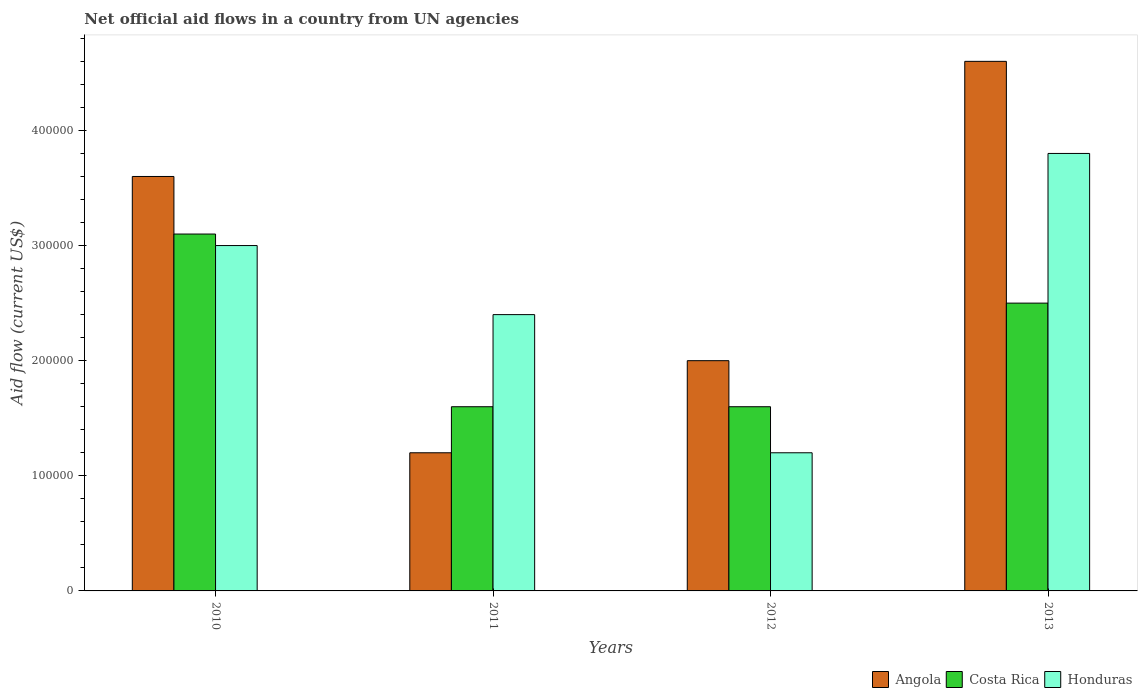How many different coloured bars are there?
Give a very brief answer. 3. Are the number of bars per tick equal to the number of legend labels?
Provide a succinct answer. Yes. Are the number of bars on each tick of the X-axis equal?
Offer a terse response. Yes. In how many cases, is the number of bars for a given year not equal to the number of legend labels?
Your answer should be very brief. 0. What is the net official aid flow in Honduras in 2011?
Give a very brief answer. 2.40e+05. Across all years, what is the maximum net official aid flow in Honduras?
Your answer should be compact. 3.80e+05. Across all years, what is the minimum net official aid flow in Honduras?
Offer a terse response. 1.20e+05. What is the total net official aid flow in Costa Rica in the graph?
Offer a very short reply. 8.80e+05. What is the difference between the net official aid flow in Angola in 2010 and that in 2013?
Make the answer very short. -1.00e+05. What is the difference between the net official aid flow in Costa Rica in 2011 and the net official aid flow in Angola in 2012?
Offer a terse response. -4.00e+04. In the year 2010, what is the difference between the net official aid flow in Honduras and net official aid flow in Angola?
Your answer should be very brief. -6.00e+04. In how many years, is the net official aid flow in Costa Rica greater than 320000 US$?
Provide a short and direct response. 0. What is the ratio of the net official aid flow in Angola in 2012 to that in 2013?
Provide a short and direct response. 0.43. Is the difference between the net official aid flow in Honduras in 2011 and 2013 greater than the difference between the net official aid flow in Angola in 2011 and 2013?
Provide a succinct answer. Yes. What is the difference between the highest and the second highest net official aid flow in Costa Rica?
Give a very brief answer. 6.00e+04. What is the difference between the highest and the lowest net official aid flow in Angola?
Offer a very short reply. 3.40e+05. Is the sum of the net official aid flow in Honduras in 2011 and 2013 greater than the maximum net official aid flow in Angola across all years?
Give a very brief answer. Yes. What does the 3rd bar from the left in 2012 represents?
Your response must be concise. Honduras. What does the 1st bar from the right in 2012 represents?
Ensure brevity in your answer.  Honduras. Is it the case that in every year, the sum of the net official aid flow in Angola and net official aid flow in Honduras is greater than the net official aid flow in Costa Rica?
Keep it short and to the point. Yes. How many bars are there?
Your response must be concise. 12. Where does the legend appear in the graph?
Provide a short and direct response. Bottom right. How are the legend labels stacked?
Ensure brevity in your answer.  Horizontal. What is the title of the graph?
Offer a very short reply. Net official aid flows in a country from UN agencies. What is the Aid flow (current US$) in Angola in 2010?
Offer a very short reply. 3.60e+05. What is the Aid flow (current US$) in Honduras in 2010?
Ensure brevity in your answer.  3.00e+05. What is the Aid flow (current US$) of Costa Rica in 2011?
Offer a very short reply. 1.60e+05. What is the Aid flow (current US$) in Honduras in 2011?
Offer a terse response. 2.40e+05. What is the Aid flow (current US$) of Angola in 2012?
Your answer should be very brief. 2.00e+05. What is the Aid flow (current US$) in Costa Rica in 2012?
Make the answer very short. 1.60e+05. What is the Aid flow (current US$) of Costa Rica in 2013?
Keep it short and to the point. 2.50e+05. What is the Aid flow (current US$) of Honduras in 2013?
Ensure brevity in your answer.  3.80e+05. Across all years, what is the minimum Aid flow (current US$) in Costa Rica?
Your response must be concise. 1.60e+05. What is the total Aid flow (current US$) in Angola in the graph?
Make the answer very short. 1.14e+06. What is the total Aid flow (current US$) in Costa Rica in the graph?
Offer a very short reply. 8.80e+05. What is the total Aid flow (current US$) in Honduras in the graph?
Your answer should be very brief. 1.04e+06. What is the difference between the Aid flow (current US$) in Angola in 2010 and that in 2011?
Give a very brief answer. 2.40e+05. What is the difference between the Aid flow (current US$) of Costa Rica in 2010 and that in 2011?
Keep it short and to the point. 1.50e+05. What is the difference between the Aid flow (current US$) in Honduras in 2010 and that in 2011?
Your answer should be very brief. 6.00e+04. What is the difference between the Aid flow (current US$) in Honduras in 2010 and that in 2012?
Offer a very short reply. 1.80e+05. What is the difference between the Aid flow (current US$) in Costa Rica in 2010 and that in 2013?
Keep it short and to the point. 6.00e+04. What is the difference between the Aid flow (current US$) in Angola in 2011 and that in 2012?
Your answer should be very brief. -8.00e+04. What is the difference between the Aid flow (current US$) of Honduras in 2011 and that in 2012?
Your response must be concise. 1.20e+05. What is the difference between the Aid flow (current US$) of Angola in 2011 and that in 2013?
Offer a very short reply. -3.40e+05. What is the difference between the Aid flow (current US$) in Honduras in 2011 and that in 2013?
Provide a short and direct response. -1.40e+05. What is the difference between the Aid flow (current US$) of Costa Rica in 2012 and that in 2013?
Provide a short and direct response. -9.00e+04. What is the difference between the Aid flow (current US$) in Honduras in 2012 and that in 2013?
Ensure brevity in your answer.  -2.60e+05. What is the difference between the Aid flow (current US$) in Angola in 2010 and the Aid flow (current US$) in Honduras in 2011?
Provide a succinct answer. 1.20e+05. What is the difference between the Aid flow (current US$) in Costa Rica in 2010 and the Aid flow (current US$) in Honduras in 2012?
Provide a short and direct response. 1.90e+05. What is the difference between the Aid flow (current US$) in Costa Rica in 2010 and the Aid flow (current US$) in Honduras in 2013?
Offer a terse response. -7.00e+04. What is the difference between the Aid flow (current US$) in Angola in 2011 and the Aid flow (current US$) in Costa Rica in 2012?
Your answer should be compact. -4.00e+04. What is the difference between the Aid flow (current US$) in Angola in 2011 and the Aid flow (current US$) in Honduras in 2012?
Offer a very short reply. 0. What is the difference between the Aid flow (current US$) of Angola in 2011 and the Aid flow (current US$) of Costa Rica in 2013?
Provide a short and direct response. -1.30e+05. What is the difference between the Aid flow (current US$) of Costa Rica in 2011 and the Aid flow (current US$) of Honduras in 2013?
Provide a short and direct response. -2.20e+05. What is the difference between the Aid flow (current US$) in Angola in 2012 and the Aid flow (current US$) in Honduras in 2013?
Provide a succinct answer. -1.80e+05. What is the difference between the Aid flow (current US$) in Costa Rica in 2012 and the Aid flow (current US$) in Honduras in 2013?
Provide a short and direct response. -2.20e+05. What is the average Aid flow (current US$) of Angola per year?
Offer a terse response. 2.85e+05. What is the average Aid flow (current US$) in Honduras per year?
Provide a succinct answer. 2.60e+05. In the year 2010, what is the difference between the Aid flow (current US$) in Costa Rica and Aid flow (current US$) in Honduras?
Offer a very short reply. 10000. In the year 2011, what is the difference between the Aid flow (current US$) in Angola and Aid flow (current US$) in Costa Rica?
Offer a terse response. -4.00e+04. In the year 2011, what is the difference between the Aid flow (current US$) of Angola and Aid flow (current US$) of Honduras?
Keep it short and to the point. -1.20e+05. In the year 2011, what is the difference between the Aid flow (current US$) in Costa Rica and Aid flow (current US$) in Honduras?
Ensure brevity in your answer.  -8.00e+04. In the year 2012, what is the difference between the Aid flow (current US$) in Angola and Aid flow (current US$) in Costa Rica?
Your answer should be very brief. 4.00e+04. In the year 2012, what is the difference between the Aid flow (current US$) of Costa Rica and Aid flow (current US$) of Honduras?
Keep it short and to the point. 4.00e+04. In the year 2013, what is the difference between the Aid flow (current US$) in Angola and Aid flow (current US$) in Honduras?
Your answer should be compact. 8.00e+04. In the year 2013, what is the difference between the Aid flow (current US$) of Costa Rica and Aid flow (current US$) of Honduras?
Offer a very short reply. -1.30e+05. What is the ratio of the Aid flow (current US$) of Angola in 2010 to that in 2011?
Give a very brief answer. 3. What is the ratio of the Aid flow (current US$) of Costa Rica in 2010 to that in 2011?
Offer a very short reply. 1.94. What is the ratio of the Aid flow (current US$) in Honduras in 2010 to that in 2011?
Your answer should be very brief. 1.25. What is the ratio of the Aid flow (current US$) in Costa Rica in 2010 to that in 2012?
Your answer should be compact. 1.94. What is the ratio of the Aid flow (current US$) of Angola in 2010 to that in 2013?
Give a very brief answer. 0.78. What is the ratio of the Aid flow (current US$) of Costa Rica in 2010 to that in 2013?
Your answer should be very brief. 1.24. What is the ratio of the Aid flow (current US$) of Honduras in 2010 to that in 2013?
Your answer should be compact. 0.79. What is the ratio of the Aid flow (current US$) in Angola in 2011 to that in 2012?
Make the answer very short. 0.6. What is the ratio of the Aid flow (current US$) in Honduras in 2011 to that in 2012?
Your response must be concise. 2. What is the ratio of the Aid flow (current US$) of Angola in 2011 to that in 2013?
Keep it short and to the point. 0.26. What is the ratio of the Aid flow (current US$) in Costa Rica in 2011 to that in 2013?
Make the answer very short. 0.64. What is the ratio of the Aid flow (current US$) in Honduras in 2011 to that in 2013?
Your answer should be compact. 0.63. What is the ratio of the Aid flow (current US$) of Angola in 2012 to that in 2013?
Offer a terse response. 0.43. What is the ratio of the Aid flow (current US$) in Costa Rica in 2012 to that in 2013?
Offer a terse response. 0.64. What is the ratio of the Aid flow (current US$) in Honduras in 2012 to that in 2013?
Keep it short and to the point. 0.32. What is the difference between the highest and the second highest Aid flow (current US$) in Angola?
Provide a succinct answer. 1.00e+05. What is the difference between the highest and the lowest Aid flow (current US$) in Angola?
Offer a very short reply. 3.40e+05. What is the difference between the highest and the lowest Aid flow (current US$) in Honduras?
Give a very brief answer. 2.60e+05. 